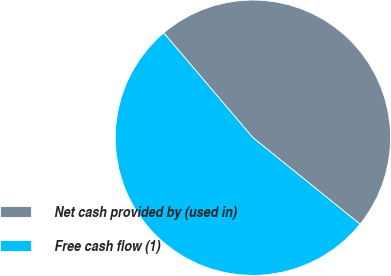<chart> <loc_0><loc_0><loc_500><loc_500><pie_chart><fcel>Net cash provided by (used in)<fcel>Free cash flow (1)<nl><fcel>47.03%<fcel>52.97%<nl></chart> 